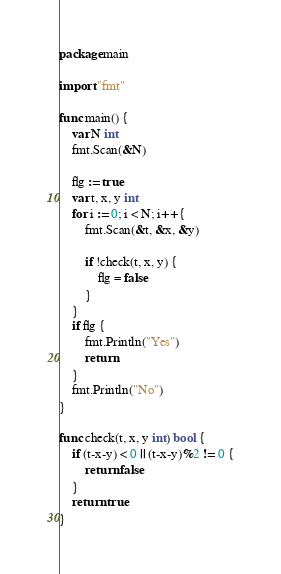<code> <loc_0><loc_0><loc_500><loc_500><_Go_>package main

import "fmt"

func main() {
	var N int
	fmt.Scan(&N)

	flg := true
	var t, x, y int
	for i := 0; i < N; i++ {
		fmt.Scan(&t, &x, &y)

		if !check(t, x, y) {
			flg = false
		}
	}
	if flg {
		fmt.Println("Yes")
		return
	}
	fmt.Println("No")
}

func check(t, x, y int) bool {
	if (t-x-y) < 0 || (t-x-y)%2 != 0 {
		return false
	}
	return true
}</code> 